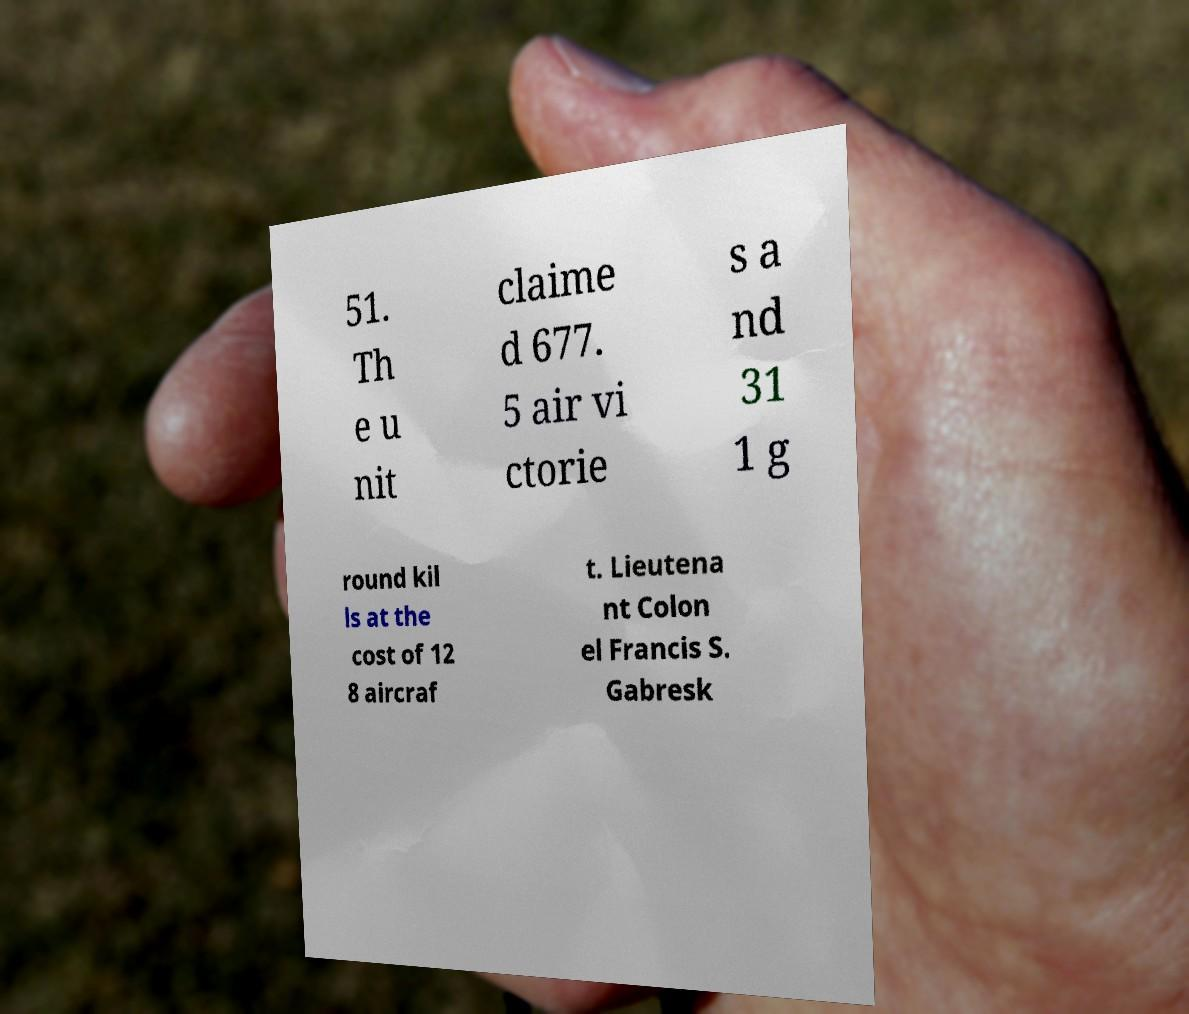I need the written content from this picture converted into text. Can you do that? 51. Th e u nit claime d 677. 5 air vi ctorie s a nd 31 1 g round kil ls at the cost of 12 8 aircraf t. Lieutena nt Colon el Francis S. Gabresk 